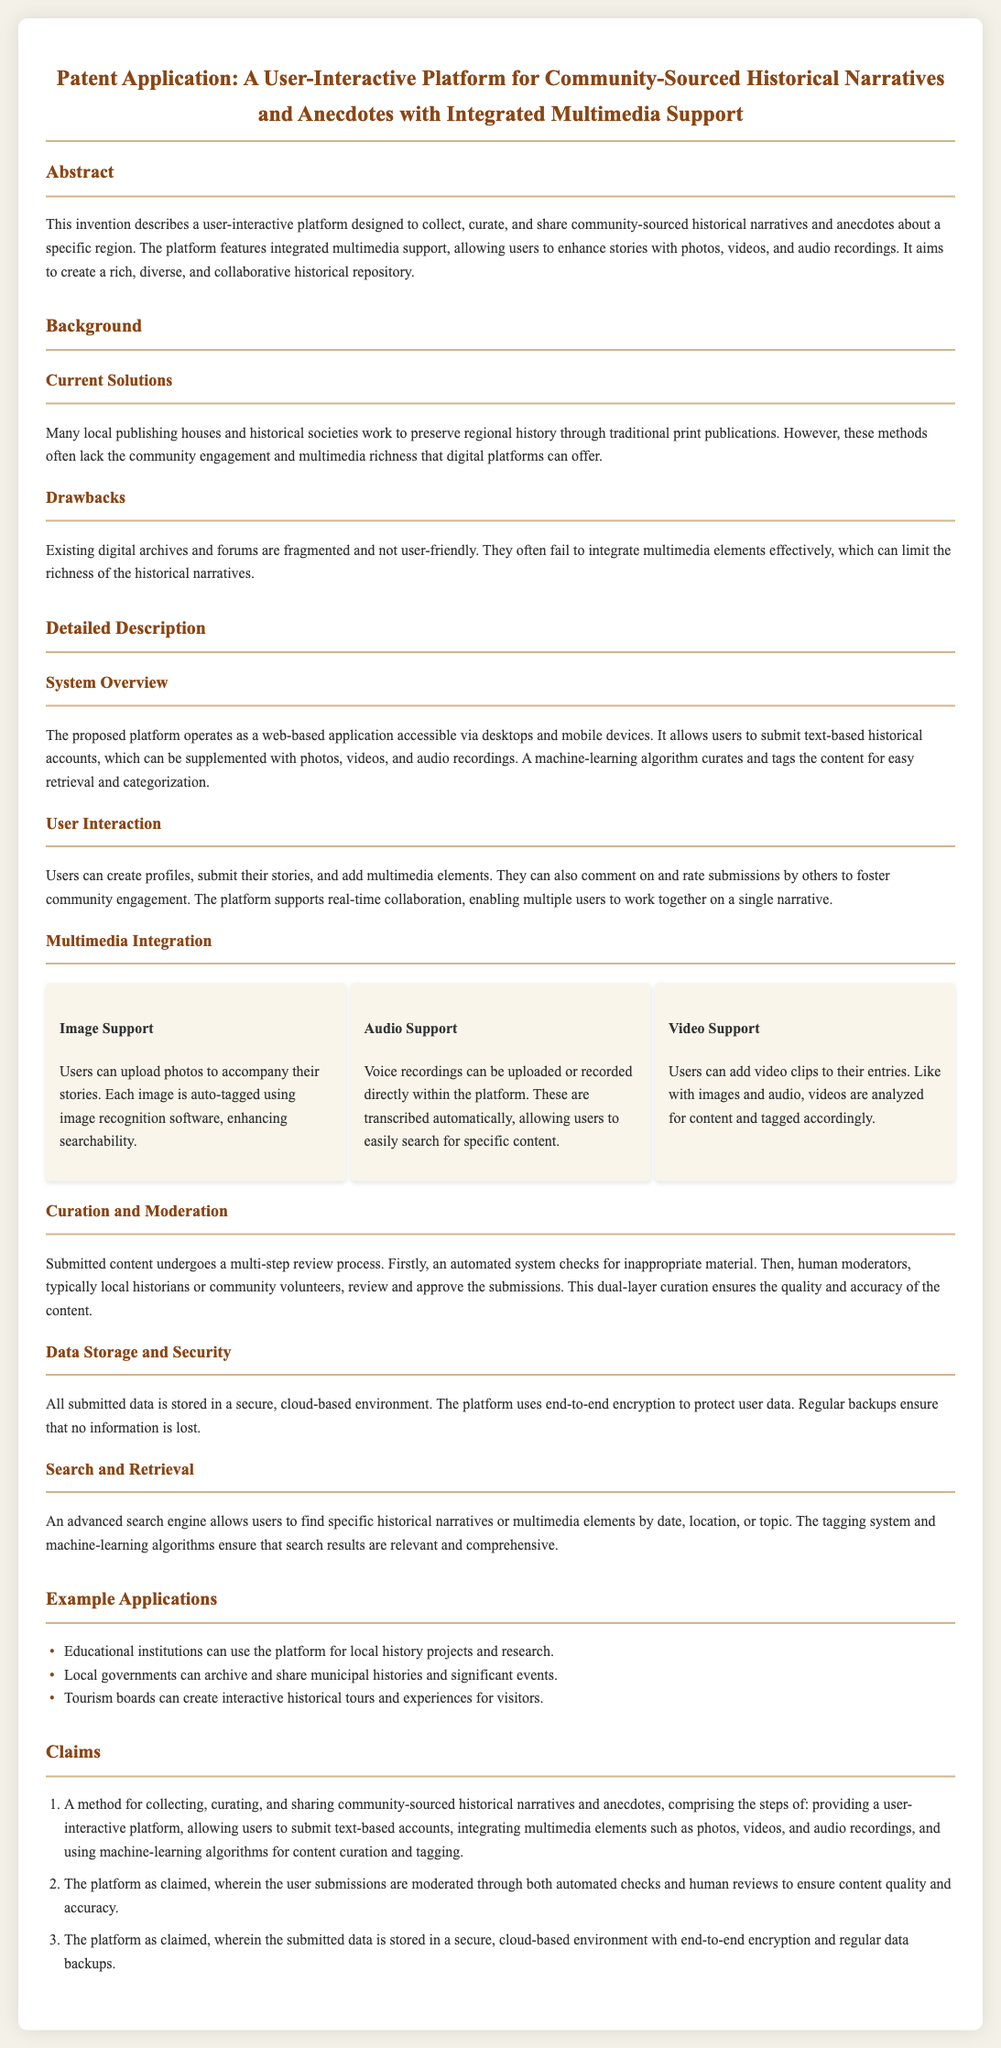What is the primary function of the platform? The platform is designed to collect, curate, and share community-sourced historical narratives and anecdotes.
Answer: Collect, curate, and share stories What types of multimedia does the platform support? The platform allows users to enhance stories with photos, videos, and audio recordings.
Answer: Photos, videos, and audio How are user submissions moderated? Submitted content undergoes a multi-step review process including automated checks and human reviews.
Answer: Automated checks and human reviews What is the primary method for content curation? Machine-learning algorithms are used for content curation and tagging.
Answer: Machine-learning algorithms What feature enhances the searchability of images? Each image is auto-tagged using image recognition software.
Answer: Auto-tagging How is user data stored? All submitted data is stored in a secure, cloud-based environment with end-to-end encryption.
Answer: Secure, cloud-based environment What type of organizations can use the platform for historical projects? Educational institutions can use the platform for local history projects and research.
Answer: Educational institutions How many claims are listed in the document? The document contains three claims related to the platform's functionality.
Answer: Three claims 